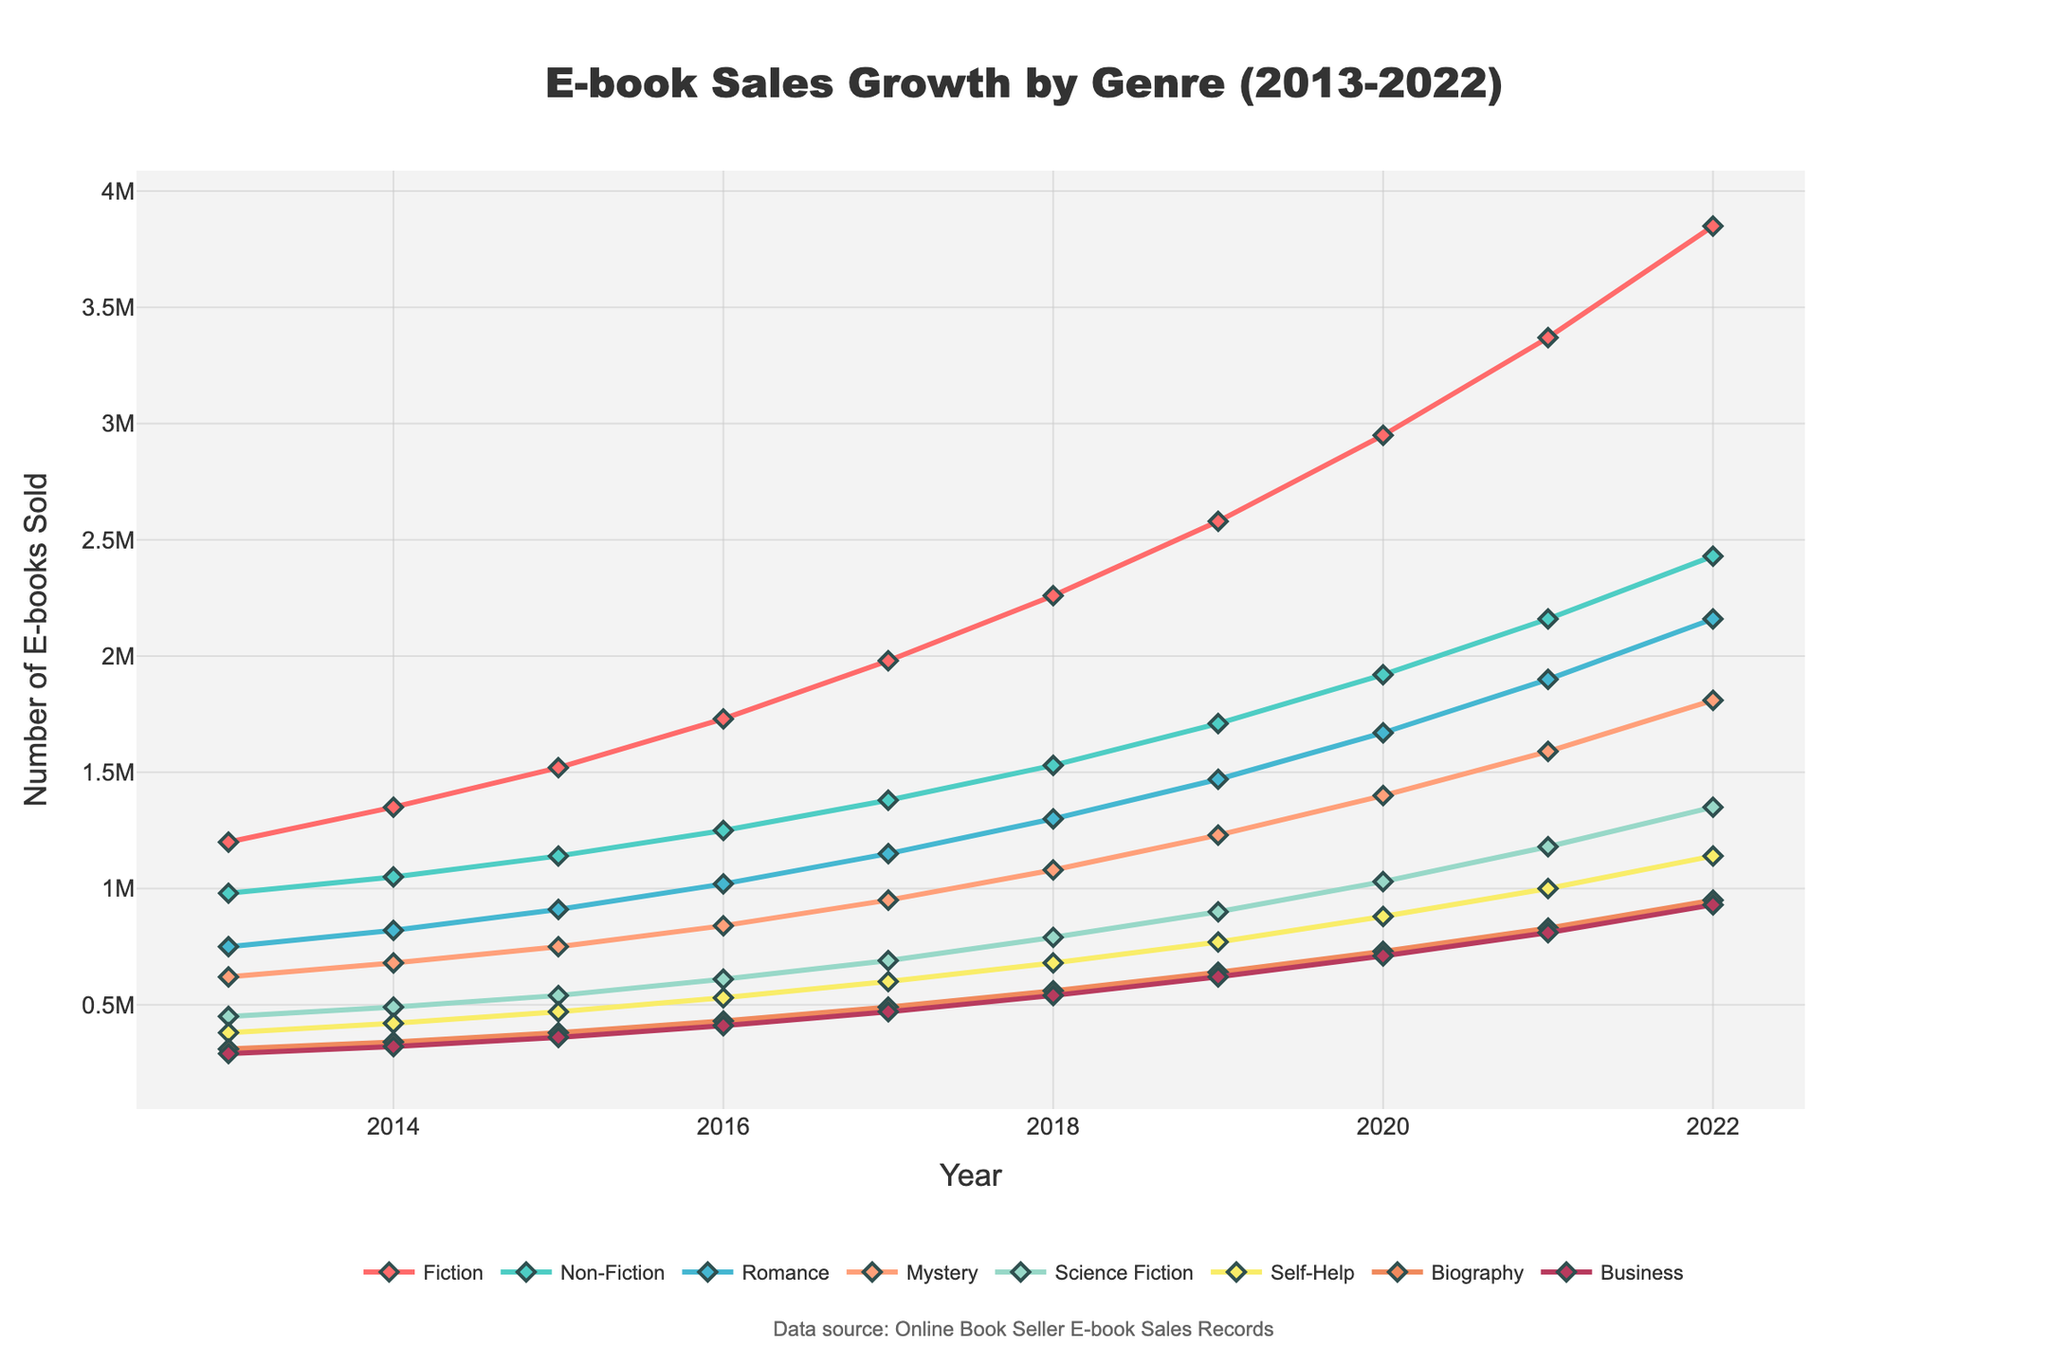Which genre had the highest sales in 2022? Look at the lines in the figure for the year 2022 and find the highest point. The Fiction genre has the highest sales with 3,850,000 e-books sold in 2022.
Answer: Fiction How did sales of Mystery books change from 2013 to 2022? Find the data points for Mystery in 2013 and 2022, and observe the difference. In 2013, Mystery is at 620,000 and in 2022, it is at 1,810,000.
Answer: Increased by 1,190,000 What was the total number of e-books sold in the genres Romance, Science Fiction, and Biography in 2017? Sum up the data points for these three genres in 2017: Romance (1,150,000), Science Fiction (690,000), and Biography (490,000). Total = 1,150,000 + 690,000 + 490,000 = 2,330,000
Answer: 2,330,000 Which two genres had the closest sales figures in 2020? Look at the data points for 2020 and compare the figures. Mystery (1,400,000) and Romance (1,670,000) have the closest figures.
Answer: Mystery and Romance In which year did Self-Help genre sales surpass the 1 million mark? Locate the year where the Self-Help genre first crosses the 1,000,000 mark. In the graph, this occurs in 2021 where it reached 1,000,000.
Answer: 2021 Which genre showed consistent growth every year from 2013 to 2022? Observe the trends and check if the line for the genre consistently rises year over year across the entire period. The genre Self-Help shows a steady increase every year from 2013 to 2022.
Answer: Self-Help What's the average growth rate of Fiction sales per year from 2013 to 2022? Calculate the total increase in Fiction sales over the period and divide it by the number of years (2022-2013 = 9 years). The increase from 2013 (1,200,000) to 2022 (3,850,000) is 3,850,000 - 1,200,000 = 2,650,000. Average growth rate = 2,650,000 / 9 ≈ 294,444 per year
Answer: 294,444 Compare the sales trend of Business and Science Fiction genres. Which genre had a higher sales growth rate over the decade? Compare the starting and ending points for both genres and calculate the total increase for each genre. Business increased from 290,000 in 2013 to 930,000 in 2022, an increase of 640,000, whereas Science Fiction increased from 450,000 to 1,350,000, an increase of 900,000. Science Fiction had a higher growth rate.
Answer: Science Fiction Identify the genre with the least sales in 2014 and state its sales figure. Look at the values for 2014 and find the smallest number. The Business genre had the least sales with 320,000 units sold.
Answer: Business What was the average number of Non-Fiction e-books sold per year between 2013 and 2022? Add up the sales figures for the Non-Fiction genre from 2013 to 2022 and divide by the number of years (10). Total Non-Fiction sales: 15,390,000. Average = 15,390,000 / 10 = 1,539,000 per year.
Answer: 1,539,000 